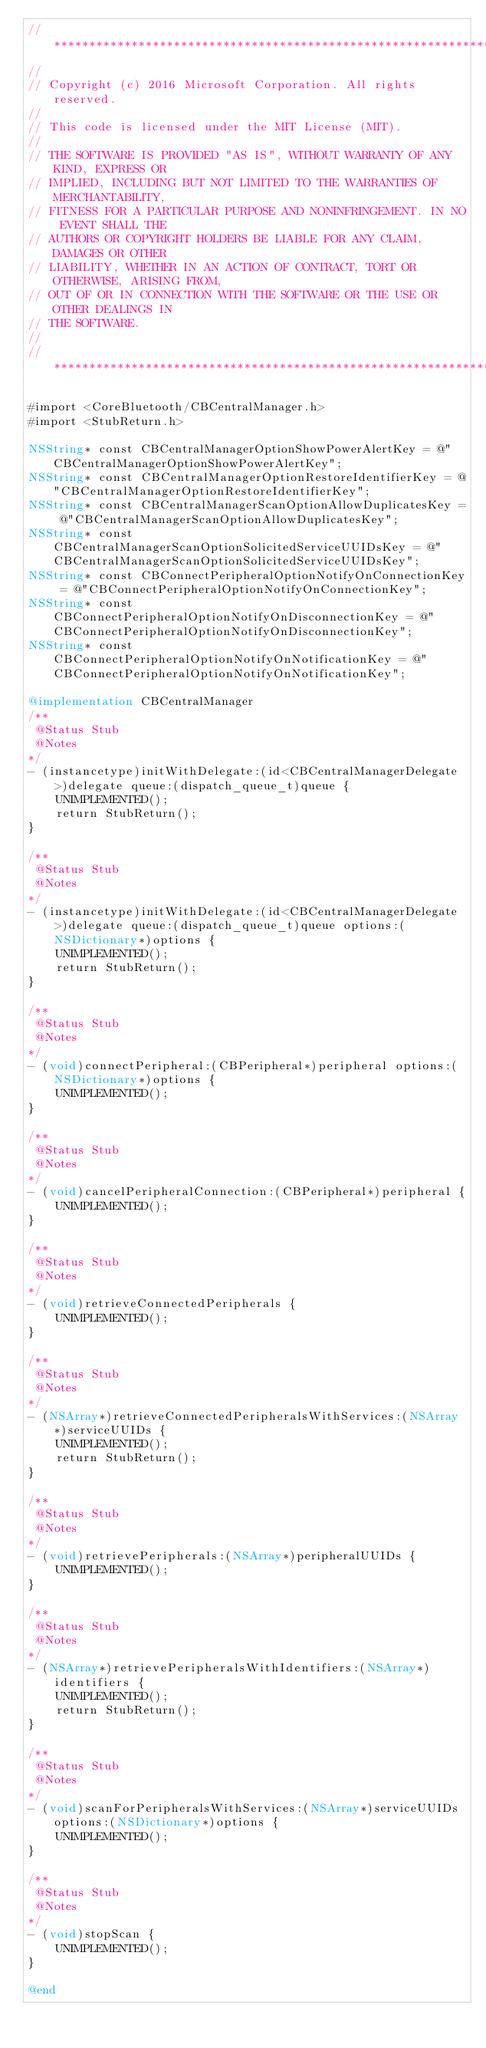<code> <loc_0><loc_0><loc_500><loc_500><_ObjectiveC_>//******************************************************************************
//
// Copyright (c) 2016 Microsoft Corporation. All rights reserved.
//
// This code is licensed under the MIT License (MIT).
//
// THE SOFTWARE IS PROVIDED "AS IS", WITHOUT WARRANTY OF ANY KIND, EXPRESS OR
// IMPLIED, INCLUDING BUT NOT LIMITED TO THE WARRANTIES OF MERCHANTABILITY,
// FITNESS FOR A PARTICULAR PURPOSE AND NONINFRINGEMENT. IN NO EVENT SHALL THE
// AUTHORS OR COPYRIGHT HOLDERS BE LIABLE FOR ANY CLAIM, DAMAGES OR OTHER
// LIABILITY, WHETHER IN AN ACTION OF CONTRACT, TORT OR OTHERWISE, ARISING FROM,
// OUT OF OR IN CONNECTION WITH THE SOFTWARE OR THE USE OR OTHER DEALINGS IN
// THE SOFTWARE.
//
//******************************************************************************

#import <CoreBluetooth/CBCentralManager.h>
#import <StubReturn.h>

NSString* const CBCentralManagerOptionShowPowerAlertKey = @"CBCentralManagerOptionShowPowerAlertKey";
NSString* const CBCentralManagerOptionRestoreIdentifierKey = @"CBCentralManagerOptionRestoreIdentifierKey";
NSString* const CBCentralManagerScanOptionAllowDuplicatesKey = @"CBCentralManagerScanOptionAllowDuplicatesKey";
NSString* const CBCentralManagerScanOptionSolicitedServiceUUIDsKey = @"CBCentralManagerScanOptionSolicitedServiceUUIDsKey";
NSString* const CBConnectPeripheralOptionNotifyOnConnectionKey = @"CBConnectPeripheralOptionNotifyOnConnectionKey";
NSString* const CBConnectPeripheralOptionNotifyOnDisconnectionKey = @"CBConnectPeripheralOptionNotifyOnDisconnectionKey";
NSString* const CBConnectPeripheralOptionNotifyOnNotificationKey = @"CBConnectPeripheralOptionNotifyOnNotificationKey";

@implementation CBCentralManager
/**
 @Status Stub
 @Notes
*/
- (instancetype)initWithDelegate:(id<CBCentralManagerDelegate>)delegate queue:(dispatch_queue_t)queue {
    UNIMPLEMENTED();
    return StubReturn();
}

/**
 @Status Stub
 @Notes
*/
- (instancetype)initWithDelegate:(id<CBCentralManagerDelegate>)delegate queue:(dispatch_queue_t)queue options:(NSDictionary*)options {
    UNIMPLEMENTED();
    return StubReturn();
}

/**
 @Status Stub
 @Notes
*/
- (void)connectPeripheral:(CBPeripheral*)peripheral options:(NSDictionary*)options {
    UNIMPLEMENTED();
}

/**
 @Status Stub
 @Notes
*/
- (void)cancelPeripheralConnection:(CBPeripheral*)peripheral {
    UNIMPLEMENTED();
}

/**
 @Status Stub
 @Notes
*/
- (void)retrieveConnectedPeripherals {
    UNIMPLEMENTED();
}

/**
 @Status Stub
 @Notes
*/
- (NSArray*)retrieveConnectedPeripheralsWithServices:(NSArray*)serviceUUIDs {
    UNIMPLEMENTED();
    return StubReturn();
}

/**
 @Status Stub
 @Notes
*/
- (void)retrievePeripherals:(NSArray*)peripheralUUIDs {
    UNIMPLEMENTED();
}

/**
 @Status Stub
 @Notes
*/
- (NSArray*)retrievePeripheralsWithIdentifiers:(NSArray*)identifiers {
    UNIMPLEMENTED();
    return StubReturn();
}

/**
 @Status Stub
 @Notes
*/
- (void)scanForPeripheralsWithServices:(NSArray*)serviceUUIDs options:(NSDictionary*)options {
    UNIMPLEMENTED();
}

/**
 @Status Stub
 @Notes
*/
- (void)stopScan {
    UNIMPLEMENTED();
}

@end
</code> 